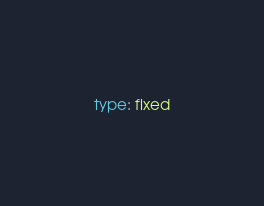Convert code to text. <code><loc_0><loc_0><loc_500><loc_500><_YAML_>type: fixed
</code> 